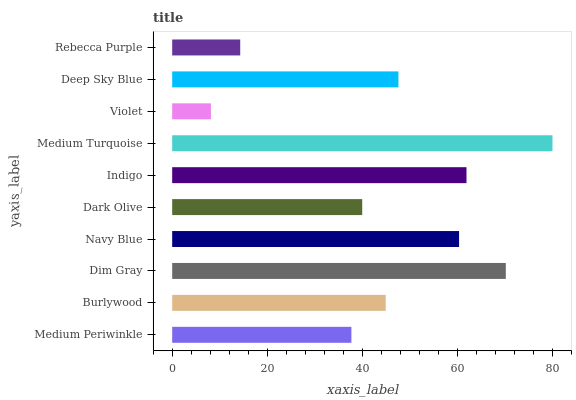Is Violet the minimum?
Answer yes or no. Yes. Is Medium Turquoise the maximum?
Answer yes or no. Yes. Is Burlywood the minimum?
Answer yes or no. No. Is Burlywood the maximum?
Answer yes or no. No. Is Burlywood greater than Medium Periwinkle?
Answer yes or no. Yes. Is Medium Periwinkle less than Burlywood?
Answer yes or no. Yes. Is Medium Periwinkle greater than Burlywood?
Answer yes or no. No. Is Burlywood less than Medium Periwinkle?
Answer yes or no. No. Is Deep Sky Blue the high median?
Answer yes or no. Yes. Is Burlywood the low median?
Answer yes or no. Yes. Is Dim Gray the high median?
Answer yes or no. No. Is Violet the low median?
Answer yes or no. No. 